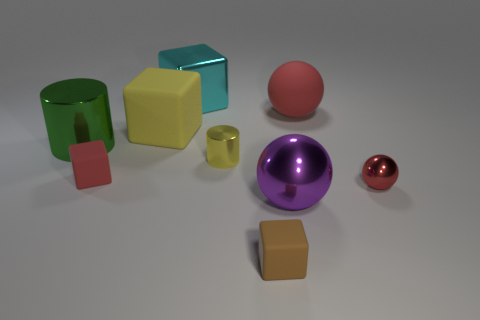Subtract all red balls. How many were subtracted if there are1red balls left? 1 Subtract 1 blocks. How many blocks are left? 3 Add 1 yellow matte blocks. How many objects exist? 10 Subtract all cylinders. How many objects are left? 7 Subtract 1 red cubes. How many objects are left? 8 Subtract all small yellow objects. Subtract all purple rubber balls. How many objects are left? 8 Add 6 large shiny cylinders. How many large shiny cylinders are left? 7 Add 9 small green spheres. How many small green spheres exist? 9 